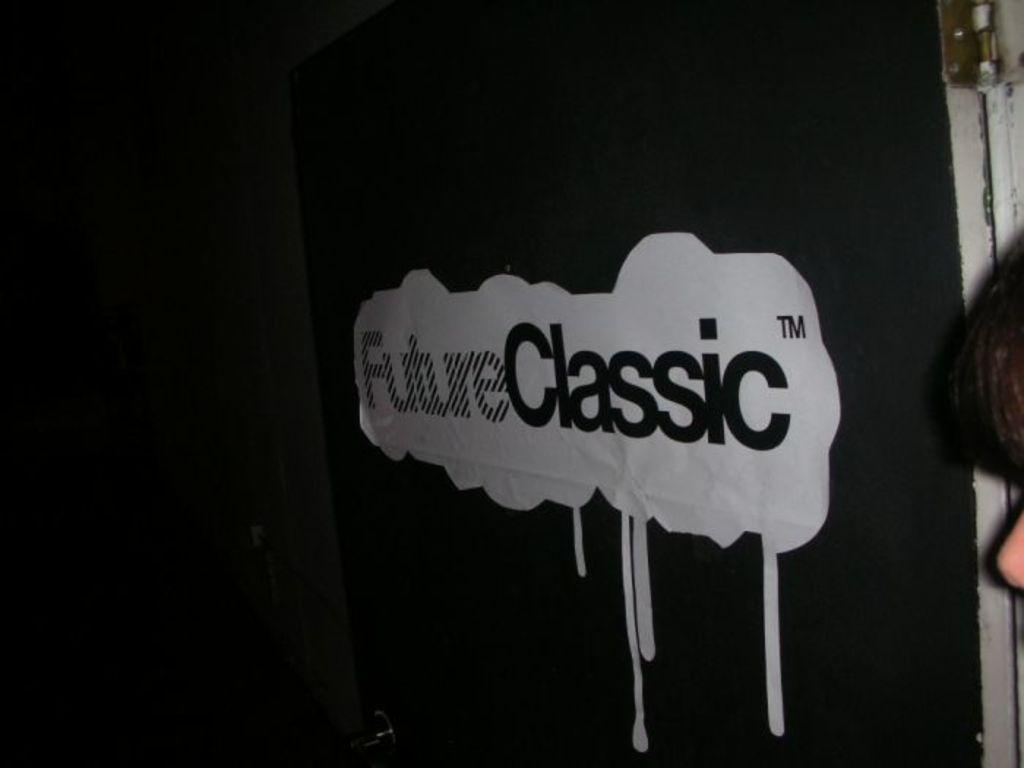What is the main color of the object in the image? The main color of the object in the image is black. What is written on the black object? There is writing on the black object. What can be seen on the right side of the image? There are other objects on the right side of the image. How would you describe the overall lighting in the image? The background of the image is dark. What type of polish is being applied to the unit in the image? There is no unit or polish present in the image; it features a black object with writing on it. What type of industry is depicted in the image? There is no specific industry depicted in the image; it only shows a black object with writing on it and other objects on the right side. 